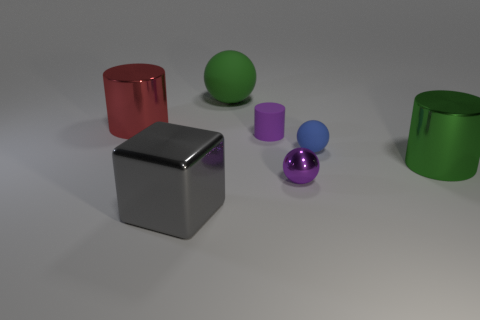How many tiny green things are there?
Offer a very short reply. 0. There is a large gray object; what shape is it?
Your answer should be very brief. Cube. How many cylinders are the same size as the purple shiny ball?
Give a very brief answer. 1. Is the shape of the small blue object the same as the purple matte object?
Offer a very short reply. No. What color is the big shiny cylinder right of the matte sphere to the left of the tiny purple cylinder?
Provide a succinct answer. Green. There is a shiny thing that is both in front of the blue rubber sphere and on the left side of the tiny metal sphere; how big is it?
Provide a succinct answer. Large. Are there any other things that have the same color as the shiny ball?
Offer a terse response. Yes. What is the shape of the purple thing that is made of the same material as the large sphere?
Keep it short and to the point. Cylinder. Does the green matte object have the same shape as the matte object that is to the right of the small purple cylinder?
Keep it short and to the point. Yes. There is a green object that is to the left of the cylinder in front of the tiny matte cylinder; what is it made of?
Provide a short and direct response. Rubber. 